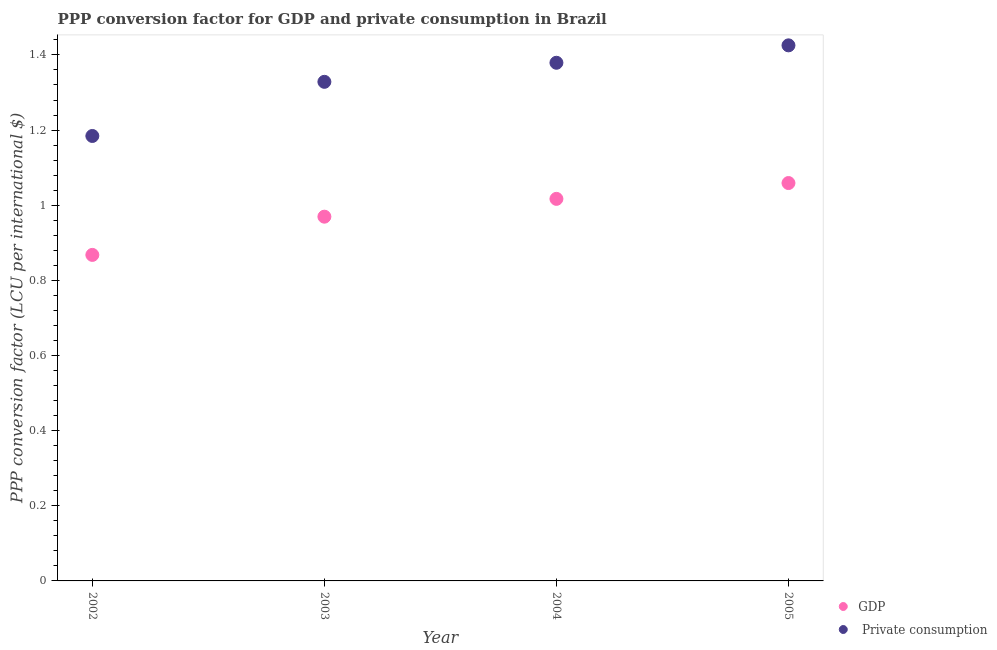What is the ppp conversion factor for private consumption in 2004?
Provide a short and direct response. 1.38. Across all years, what is the maximum ppp conversion factor for gdp?
Ensure brevity in your answer.  1.06. Across all years, what is the minimum ppp conversion factor for gdp?
Your answer should be very brief. 0.87. What is the total ppp conversion factor for private consumption in the graph?
Give a very brief answer. 5.32. What is the difference between the ppp conversion factor for private consumption in 2002 and that in 2003?
Offer a very short reply. -0.14. What is the difference between the ppp conversion factor for gdp in 2002 and the ppp conversion factor for private consumption in 2004?
Ensure brevity in your answer.  -0.51. What is the average ppp conversion factor for private consumption per year?
Provide a short and direct response. 1.33. In the year 2005, what is the difference between the ppp conversion factor for private consumption and ppp conversion factor for gdp?
Offer a terse response. 0.37. In how many years, is the ppp conversion factor for private consumption greater than 0.36 LCU?
Offer a very short reply. 4. What is the ratio of the ppp conversion factor for gdp in 2002 to that in 2004?
Your answer should be very brief. 0.85. Is the ppp conversion factor for gdp in 2003 less than that in 2004?
Provide a succinct answer. Yes. What is the difference between the highest and the second highest ppp conversion factor for private consumption?
Make the answer very short. 0.05. What is the difference between the highest and the lowest ppp conversion factor for gdp?
Provide a short and direct response. 0.19. In how many years, is the ppp conversion factor for gdp greater than the average ppp conversion factor for gdp taken over all years?
Your answer should be compact. 2. Does the ppp conversion factor for private consumption monotonically increase over the years?
Make the answer very short. Yes. How many years are there in the graph?
Ensure brevity in your answer.  4. What is the difference between two consecutive major ticks on the Y-axis?
Keep it short and to the point. 0.2. Does the graph contain any zero values?
Make the answer very short. No. Does the graph contain grids?
Provide a short and direct response. No. How many legend labels are there?
Give a very brief answer. 2. How are the legend labels stacked?
Your answer should be very brief. Vertical. What is the title of the graph?
Keep it short and to the point. PPP conversion factor for GDP and private consumption in Brazil. Does "Net savings(excluding particulate emission damage)" appear as one of the legend labels in the graph?
Your answer should be compact. No. What is the label or title of the X-axis?
Make the answer very short. Year. What is the label or title of the Y-axis?
Provide a succinct answer. PPP conversion factor (LCU per international $). What is the PPP conversion factor (LCU per international $) of GDP in 2002?
Offer a terse response. 0.87. What is the PPP conversion factor (LCU per international $) of  Private consumption in 2002?
Ensure brevity in your answer.  1.18. What is the PPP conversion factor (LCU per international $) of GDP in 2003?
Keep it short and to the point. 0.97. What is the PPP conversion factor (LCU per international $) in  Private consumption in 2003?
Offer a very short reply. 1.33. What is the PPP conversion factor (LCU per international $) in GDP in 2004?
Offer a terse response. 1.02. What is the PPP conversion factor (LCU per international $) in  Private consumption in 2004?
Offer a terse response. 1.38. What is the PPP conversion factor (LCU per international $) in GDP in 2005?
Your answer should be very brief. 1.06. What is the PPP conversion factor (LCU per international $) of  Private consumption in 2005?
Give a very brief answer. 1.43. Across all years, what is the maximum PPP conversion factor (LCU per international $) of GDP?
Offer a terse response. 1.06. Across all years, what is the maximum PPP conversion factor (LCU per international $) of  Private consumption?
Make the answer very short. 1.43. Across all years, what is the minimum PPP conversion factor (LCU per international $) of GDP?
Your answer should be very brief. 0.87. Across all years, what is the minimum PPP conversion factor (LCU per international $) of  Private consumption?
Keep it short and to the point. 1.18. What is the total PPP conversion factor (LCU per international $) in GDP in the graph?
Keep it short and to the point. 3.91. What is the total PPP conversion factor (LCU per international $) in  Private consumption in the graph?
Provide a succinct answer. 5.32. What is the difference between the PPP conversion factor (LCU per international $) of GDP in 2002 and that in 2003?
Ensure brevity in your answer.  -0.1. What is the difference between the PPP conversion factor (LCU per international $) of  Private consumption in 2002 and that in 2003?
Make the answer very short. -0.14. What is the difference between the PPP conversion factor (LCU per international $) in GDP in 2002 and that in 2004?
Keep it short and to the point. -0.15. What is the difference between the PPP conversion factor (LCU per international $) of  Private consumption in 2002 and that in 2004?
Give a very brief answer. -0.19. What is the difference between the PPP conversion factor (LCU per international $) of GDP in 2002 and that in 2005?
Provide a succinct answer. -0.19. What is the difference between the PPP conversion factor (LCU per international $) of  Private consumption in 2002 and that in 2005?
Give a very brief answer. -0.24. What is the difference between the PPP conversion factor (LCU per international $) of GDP in 2003 and that in 2004?
Your response must be concise. -0.05. What is the difference between the PPP conversion factor (LCU per international $) in  Private consumption in 2003 and that in 2004?
Give a very brief answer. -0.05. What is the difference between the PPP conversion factor (LCU per international $) in GDP in 2003 and that in 2005?
Your answer should be compact. -0.09. What is the difference between the PPP conversion factor (LCU per international $) of  Private consumption in 2003 and that in 2005?
Your response must be concise. -0.1. What is the difference between the PPP conversion factor (LCU per international $) in GDP in 2004 and that in 2005?
Your answer should be compact. -0.04. What is the difference between the PPP conversion factor (LCU per international $) in  Private consumption in 2004 and that in 2005?
Keep it short and to the point. -0.05. What is the difference between the PPP conversion factor (LCU per international $) in GDP in 2002 and the PPP conversion factor (LCU per international $) in  Private consumption in 2003?
Ensure brevity in your answer.  -0.46. What is the difference between the PPP conversion factor (LCU per international $) in GDP in 2002 and the PPP conversion factor (LCU per international $) in  Private consumption in 2004?
Make the answer very short. -0.51. What is the difference between the PPP conversion factor (LCU per international $) in GDP in 2002 and the PPP conversion factor (LCU per international $) in  Private consumption in 2005?
Provide a short and direct response. -0.56. What is the difference between the PPP conversion factor (LCU per international $) in GDP in 2003 and the PPP conversion factor (LCU per international $) in  Private consumption in 2004?
Ensure brevity in your answer.  -0.41. What is the difference between the PPP conversion factor (LCU per international $) of GDP in 2003 and the PPP conversion factor (LCU per international $) of  Private consumption in 2005?
Keep it short and to the point. -0.46. What is the difference between the PPP conversion factor (LCU per international $) in GDP in 2004 and the PPP conversion factor (LCU per international $) in  Private consumption in 2005?
Your answer should be very brief. -0.41. What is the average PPP conversion factor (LCU per international $) in GDP per year?
Offer a very short reply. 0.98. What is the average PPP conversion factor (LCU per international $) of  Private consumption per year?
Your answer should be very brief. 1.33. In the year 2002, what is the difference between the PPP conversion factor (LCU per international $) in GDP and PPP conversion factor (LCU per international $) in  Private consumption?
Ensure brevity in your answer.  -0.32. In the year 2003, what is the difference between the PPP conversion factor (LCU per international $) in GDP and PPP conversion factor (LCU per international $) in  Private consumption?
Your response must be concise. -0.36. In the year 2004, what is the difference between the PPP conversion factor (LCU per international $) in GDP and PPP conversion factor (LCU per international $) in  Private consumption?
Offer a very short reply. -0.36. In the year 2005, what is the difference between the PPP conversion factor (LCU per international $) of GDP and PPP conversion factor (LCU per international $) of  Private consumption?
Offer a terse response. -0.37. What is the ratio of the PPP conversion factor (LCU per international $) of GDP in 2002 to that in 2003?
Your answer should be compact. 0.9. What is the ratio of the PPP conversion factor (LCU per international $) in  Private consumption in 2002 to that in 2003?
Give a very brief answer. 0.89. What is the ratio of the PPP conversion factor (LCU per international $) in GDP in 2002 to that in 2004?
Offer a very short reply. 0.85. What is the ratio of the PPP conversion factor (LCU per international $) of  Private consumption in 2002 to that in 2004?
Ensure brevity in your answer.  0.86. What is the ratio of the PPP conversion factor (LCU per international $) in GDP in 2002 to that in 2005?
Give a very brief answer. 0.82. What is the ratio of the PPP conversion factor (LCU per international $) in  Private consumption in 2002 to that in 2005?
Make the answer very short. 0.83. What is the ratio of the PPP conversion factor (LCU per international $) of GDP in 2003 to that in 2004?
Provide a short and direct response. 0.95. What is the ratio of the PPP conversion factor (LCU per international $) in  Private consumption in 2003 to that in 2004?
Your response must be concise. 0.96. What is the ratio of the PPP conversion factor (LCU per international $) in GDP in 2003 to that in 2005?
Provide a short and direct response. 0.92. What is the ratio of the PPP conversion factor (LCU per international $) in  Private consumption in 2003 to that in 2005?
Ensure brevity in your answer.  0.93. What is the ratio of the PPP conversion factor (LCU per international $) of GDP in 2004 to that in 2005?
Offer a terse response. 0.96. What is the ratio of the PPP conversion factor (LCU per international $) of  Private consumption in 2004 to that in 2005?
Provide a short and direct response. 0.97. What is the difference between the highest and the second highest PPP conversion factor (LCU per international $) of GDP?
Give a very brief answer. 0.04. What is the difference between the highest and the second highest PPP conversion factor (LCU per international $) of  Private consumption?
Keep it short and to the point. 0.05. What is the difference between the highest and the lowest PPP conversion factor (LCU per international $) of GDP?
Your answer should be compact. 0.19. What is the difference between the highest and the lowest PPP conversion factor (LCU per international $) of  Private consumption?
Your response must be concise. 0.24. 